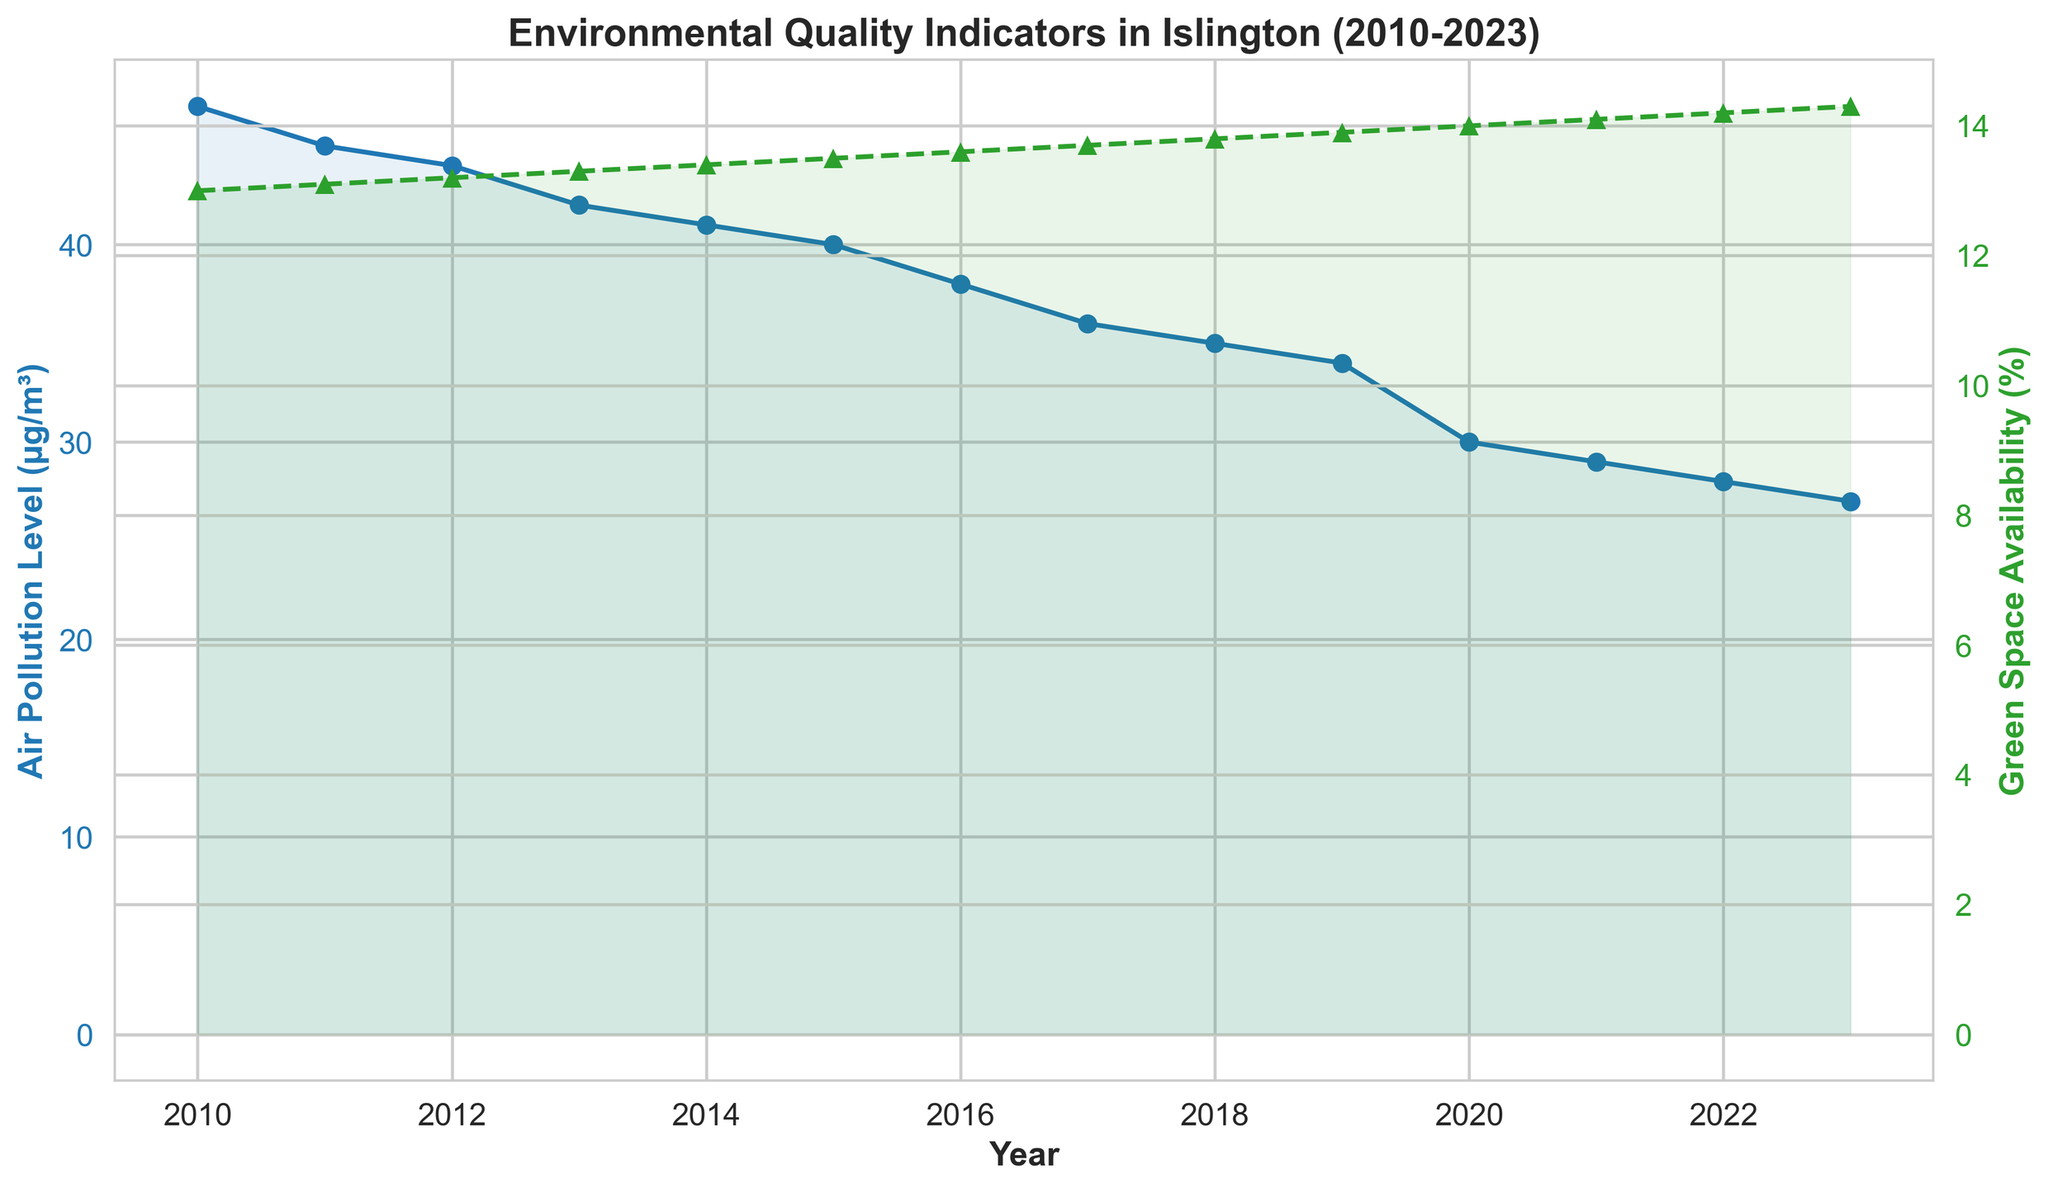What trend is observable for air pollution levels from 2010 to 2023? Air pollution levels show a consistent decline from 47 µg/m³ in 2010 to 27 µg/m³ in 2023
Answer: Consistent decline How does green space availability change between 2010 and 2023? Green space availability consistently increases from 13.0% in 2010 to 14.3% in 2023
Answer: Consistent increase What is the difference in air pollution levels between 2010 and 2023? Subtract the air pollution level in 2023 (27 µg/m³) from the level in 2010 (47 µg/m³): 47 - 27 = 20 µg/m³
Answer: 20 µg/m³ In which year did green space availability surpass 14% for the first time? Green space availability surpasses 14% for the first time in 2020 (14.0%)
Answer: 2020 By how much did air pollution levels decrease from 2019 to 2020? Subtract air pollution level in 2020 (30 µg/m³) from the level in 2019 (34 µg/m³): 34 - 30 = 4 µg/m³
Answer: 4 µg/m³ Which indicator has a more drastic visual change over the years? Comparing the slopes of the lines, air pollution levels have a more dramatic visual decline compared to the gradual increase in green space availability
Answer: Air pollution levels How many years did it take for the air pollution level to decrease by 10 µg/m³ starting from 2018? Air pollution levels in 2018 were 35 µg/m³. To decrease by 10 µg/m³, the level should reach 25 µg/m³. However, by 2023 it only reaches 27 µg/m³. So, the decline over this period is 35 - 27 = 8 µg/m³ in 5 years
Answer: More than 5 years During which years is the air pollution level lower than 40 µg/m³? The air pollution level is lower than 40 µg/m³ from 2016 onward
Answer: 2016-2023 What is the average green space availability percentage from 2010 to 2023? Sum the green space availability percentages and divide by the number of years: (13.0 + 13.1 + 13.2 + 13.3 + 13.4 + 13.5 + 13.6 + 13.7 + 13.8 + 13.9 + 14.0 + 14.1 + 14.2 + 14.3) / 14 = 13.575%
Answer: 13.58% Does the trend in green space availability appear linear or non-linear? The green space availability shows a consistent and steady increase over the years, suggesting a linear trend
Answer: Linear 